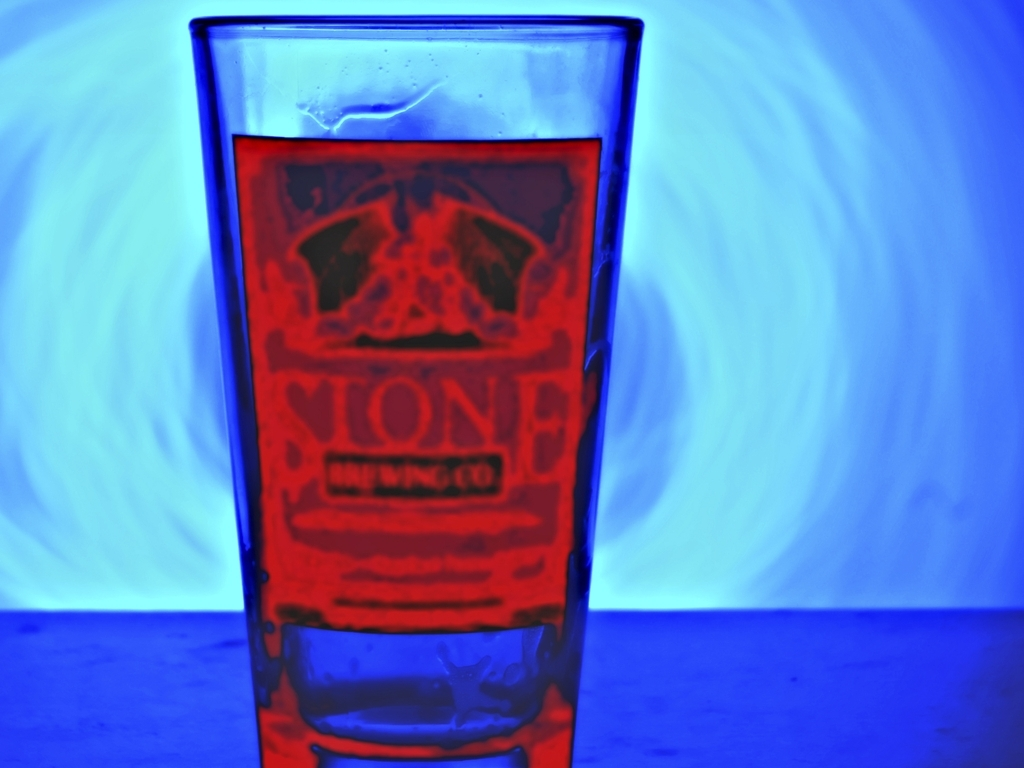What could be the potential setting or occasion for such lighting and color scheme in the image? This lighting and color scheme could suggest a social setting, possibly an event or a location with a contemporary vibe, like a bar or an art gallery. The dramatic lighting could be intentional to create a specific mood for an event, such as a product launch or a promotional party, where the use of thematic coloring enhances the visual experience Could the presence of the glass have any specific significance? Absolutely, the glass, particularly with the distinct branding visible, could signify a tasting event for a brewery, for instance. The intended focus on the glass suggests that the beverage it represents is the key element, likely appealing to connoisseurs or enthusiasts gathered for a special occasion to sample and appreciate new or exclusive brews. 